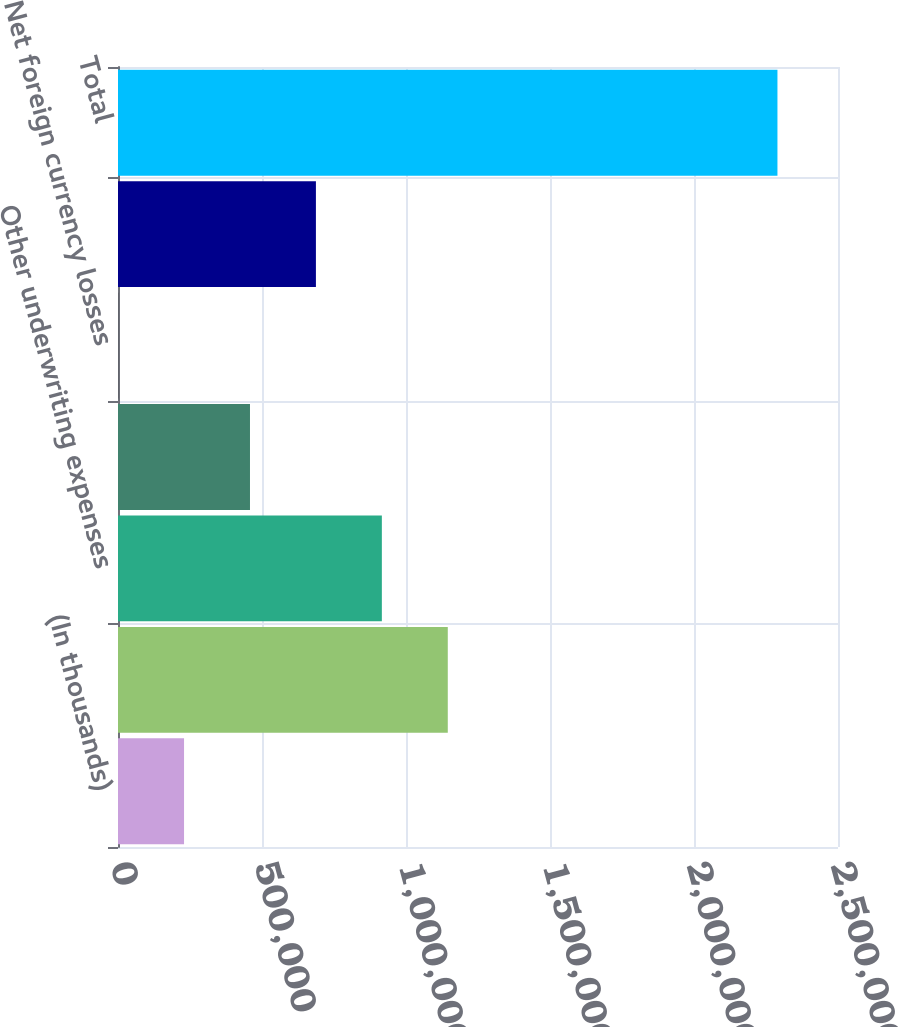<chart> <loc_0><loc_0><loc_500><loc_500><bar_chart><fcel>(In thousands)<fcel>Amortization of deferred<fcel>Other underwriting expenses<fcel>Service company expenses<fcel>Net foreign currency losses<fcel>Other costs and expenses<fcel>Total<nl><fcel>229335<fcel>1.14508e+06<fcel>916140<fcel>458270<fcel>400<fcel>687205<fcel>2.28975e+06<nl></chart> 